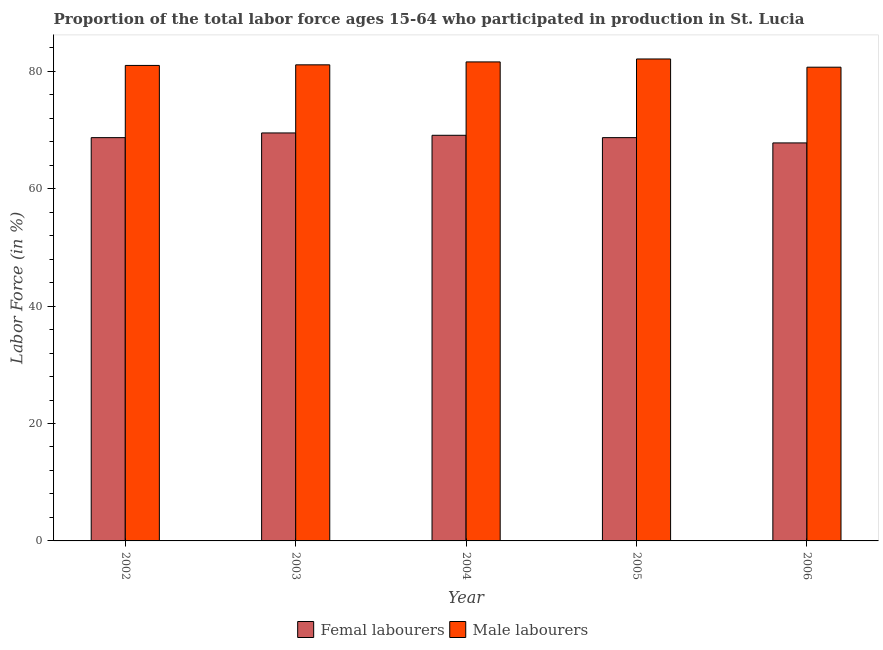How many groups of bars are there?
Provide a succinct answer. 5. Are the number of bars per tick equal to the number of legend labels?
Your answer should be compact. Yes. How many bars are there on the 1st tick from the left?
Offer a terse response. 2. How many bars are there on the 2nd tick from the right?
Provide a succinct answer. 2. What is the label of the 3rd group of bars from the left?
Keep it short and to the point. 2004. In how many cases, is the number of bars for a given year not equal to the number of legend labels?
Make the answer very short. 0. What is the percentage of male labour force in 2006?
Make the answer very short. 80.7. Across all years, what is the maximum percentage of female labor force?
Keep it short and to the point. 69.5. Across all years, what is the minimum percentage of female labor force?
Keep it short and to the point. 67.8. In which year was the percentage of female labor force minimum?
Your answer should be very brief. 2006. What is the total percentage of male labour force in the graph?
Provide a short and direct response. 406.5. What is the difference between the percentage of male labour force in 2005 and that in 2006?
Offer a very short reply. 1.4. What is the difference between the percentage of female labor force in 2003 and the percentage of male labour force in 2006?
Ensure brevity in your answer.  1.7. What is the average percentage of male labour force per year?
Your answer should be very brief. 81.3. In how many years, is the percentage of female labor force greater than 28 %?
Your answer should be very brief. 5. What is the ratio of the percentage of male labour force in 2005 to that in 2006?
Offer a terse response. 1.02. Is the difference between the percentage of female labor force in 2004 and 2006 greater than the difference between the percentage of male labour force in 2004 and 2006?
Give a very brief answer. No. What is the difference between the highest and the lowest percentage of female labor force?
Your answer should be compact. 1.7. What does the 1st bar from the left in 2006 represents?
Keep it short and to the point. Femal labourers. What does the 2nd bar from the right in 2005 represents?
Make the answer very short. Femal labourers. How many years are there in the graph?
Ensure brevity in your answer.  5. Are the values on the major ticks of Y-axis written in scientific E-notation?
Make the answer very short. No. Does the graph contain grids?
Make the answer very short. No. Where does the legend appear in the graph?
Make the answer very short. Bottom center. How many legend labels are there?
Offer a terse response. 2. What is the title of the graph?
Your answer should be very brief. Proportion of the total labor force ages 15-64 who participated in production in St. Lucia. Does "Start a business" appear as one of the legend labels in the graph?
Your answer should be compact. No. What is the label or title of the X-axis?
Offer a terse response. Year. What is the label or title of the Y-axis?
Your answer should be compact. Labor Force (in %). What is the Labor Force (in %) of Femal labourers in 2002?
Offer a very short reply. 68.7. What is the Labor Force (in %) in Male labourers in 2002?
Provide a short and direct response. 81. What is the Labor Force (in %) in Femal labourers in 2003?
Provide a succinct answer. 69.5. What is the Labor Force (in %) of Male labourers in 2003?
Ensure brevity in your answer.  81.1. What is the Labor Force (in %) of Femal labourers in 2004?
Give a very brief answer. 69.1. What is the Labor Force (in %) in Male labourers in 2004?
Ensure brevity in your answer.  81.6. What is the Labor Force (in %) in Femal labourers in 2005?
Your response must be concise. 68.7. What is the Labor Force (in %) in Male labourers in 2005?
Provide a succinct answer. 82.1. What is the Labor Force (in %) of Femal labourers in 2006?
Keep it short and to the point. 67.8. What is the Labor Force (in %) of Male labourers in 2006?
Offer a terse response. 80.7. Across all years, what is the maximum Labor Force (in %) of Femal labourers?
Provide a succinct answer. 69.5. Across all years, what is the maximum Labor Force (in %) in Male labourers?
Make the answer very short. 82.1. Across all years, what is the minimum Labor Force (in %) in Femal labourers?
Your answer should be very brief. 67.8. Across all years, what is the minimum Labor Force (in %) of Male labourers?
Ensure brevity in your answer.  80.7. What is the total Labor Force (in %) of Femal labourers in the graph?
Your response must be concise. 343.8. What is the total Labor Force (in %) in Male labourers in the graph?
Your response must be concise. 406.5. What is the difference between the Labor Force (in %) of Femal labourers in 2002 and that in 2004?
Your answer should be compact. -0.4. What is the difference between the Labor Force (in %) in Femal labourers in 2002 and that in 2005?
Make the answer very short. 0. What is the difference between the Labor Force (in %) of Male labourers in 2002 and that in 2005?
Give a very brief answer. -1.1. What is the difference between the Labor Force (in %) in Femal labourers in 2002 and that in 2006?
Give a very brief answer. 0.9. What is the difference between the Labor Force (in %) of Male labourers in 2002 and that in 2006?
Make the answer very short. 0.3. What is the difference between the Labor Force (in %) of Male labourers in 2003 and that in 2004?
Your answer should be compact. -0.5. What is the difference between the Labor Force (in %) of Femal labourers in 2003 and that in 2005?
Give a very brief answer. 0.8. What is the difference between the Labor Force (in %) in Femal labourers in 2004 and that in 2005?
Ensure brevity in your answer.  0.4. What is the difference between the Labor Force (in %) in Male labourers in 2004 and that in 2005?
Make the answer very short. -0.5. What is the difference between the Labor Force (in %) of Male labourers in 2004 and that in 2006?
Provide a short and direct response. 0.9. What is the difference between the Labor Force (in %) of Femal labourers in 2005 and that in 2006?
Your response must be concise. 0.9. What is the difference between the Labor Force (in %) in Male labourers in 2005 and that in 2006?
Make the answer very short. 1.4. What is the difference between the Labor Force (in %) of Femal labourers in 2002 and the Labor Force (in %) of Male labourers in 2003?
Ensure brevity in your answer.  -12.4. What is the difference between the Labor Force (in %) in Femal labourers in 2002 and the Labor Force (in %) in Male labourers in 2004?
Provide a short and direct response. -12.9. What is the difference between the Labor Force (in %) of Femal labourers in 2003 and the Labor Force (in %) of Male labourers in 2005?
Provide a short and direct response. -12.6. What is the difference between the Labor Force (in %) in Femal labourers in 2003 and the Labor Force (in %) in Male labourers in 2006?
Offer a very short reply. -11.2. What is the difference between the Labor Force (in %) in Femal labourers in 2004 and the Labor Force (in %) in Male labourers in 2005?
Offer a very short reply. -13. What is the difference between the Labor Force (in %) in Femal labourers in 2004 and the Labor Force (in %) in Male labourers in 2006?
Ensure brevity in your answer.  -11.6. What is the average Labor Force (in %) of Femal labourers per year?
Offer a very short reply. 68.76. What is the average Labor Force (in %) in Male labourers per year?
Offer a very short reply. 81.3. In the year 2002, what is the difference between the Labor Force (in %) of Femal labourers and Labor Force (in %) of Male labourers?
Your answer should be compact. -12.3. In the year 2003, what is the difference between the Labor Force (in %) in Femal labourers and Labor Force (in %) in Male labourers?
Your response must be concise. -11.6. In the year 2004, what is the difference between the Labor Force (in %) of Femal labourers and Labor Force (in %) of Male labourers?
Your response must be concise. -12.5. What is the ratio of the Labor Force (in %) in Femal labourers in 2002 to that in 2003?
Ensure brevity in your answer.  0.99. What is the ratio of the Labor Force (in %) of Male labourers in 2002 to that in 2003?
Provide a succinct answer. 1. What is the ratio of the Labor Force (in %) of Femal labourers in 2002 to that in 2004?
Give a very brief answer. 0.99. What is the ratio of the Labor Force (in %) of Femal labourers in 2002 to that in 2005?
Your response must be concise. 1. What is the ratio of the Labor Force (in %) of Male labourers in 2002 to that in 2005?
Your answer should be compact. 0.99. What is the ratio of the Labor Force (in %) in Femal labourers in 2002 to that in 2006?
Keep it short and to the point. 1.01. What is the ratio of the Labor Force (in %) of Male labourers in 2002 to that in 2006?
Keep it short and to the point. 1. What is the ratio of the Labor Force (in %) in Femal labourers in 2003 to that in 2004?
Offer a terse response. 1.01. What is the ratio of the Labor Force (in %) of Male labourers in 2003 to that in 2004?
Ensure brevity in your answer.  0.99. What is the ratio of the Labor Force (in %) in Femal labourers in 2003 to that in 2005?
Ensure brevity in your answer.  1.01. What is the ratio of the Labor Force (in %) of Femal labourers in 2003 to that in 2006?
Offer a very short reply. 1.03. What is the ratio of the Labor Force (in %) of Femal labourers in 2004 to that in 2006?
Your answer should be very brief. 1.02. What is the ratio of the Labor Force (in %) in Male labourers in 2004 to that in 2006?
Your answer should be compact. 1.01. What is the ratio of the Labor Force (in %) in Femal labourers in 2005 to that in 2006?
Your answer should be very brief. 1.01. What is the ratio of the Labor Force (in %) in Male labourers in 2005 to that in 2006?
Your answer should be compact. 1.02. What is the difference between the highest and the lowest Labor Force (in %) in Femal labourers?
Your answer should be compact. 1.7. What is the difference between the highest and the lowest Labor Force (in %) of Male labourers?
Provide a short and direct response. 1.4. 